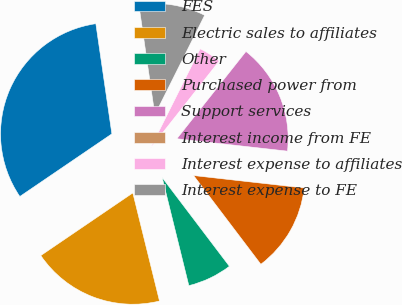Convert chart to OTSL. <chart><loc_0><loc_0><loc_500><loc_500><pie_chart><fcel>FES<fcel>Electric sales to affiliates<fcel>Other<fcel>Purchased power from<fcel>Support services<fcel>Interest income from FE<fcel>Interest expense to affiliates<fcel>Interest expense to FE<nl><fcel>32.21%<fcel>19.34%<fcel>6.47%<fcel>12.9%<fcel>16.12%<fcel>0.03%<fcel>3.25%<fcel>9.68%<nl></chart> 